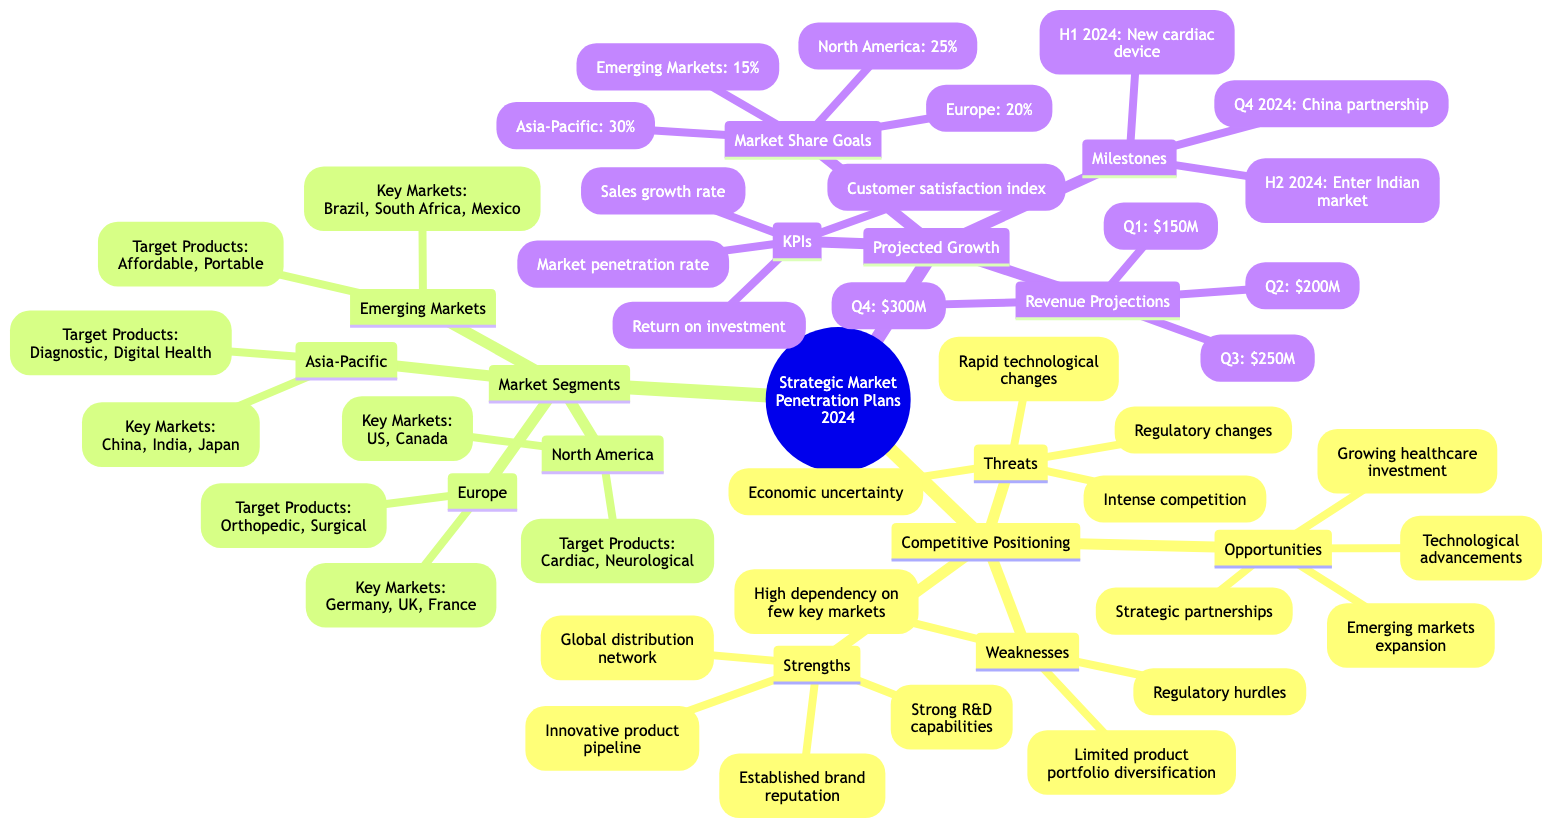What are the strengths listed under competitive positioning? The strengths are explicitly stated in the Competitive Positioning section of the mind map. They include "Innovative product pipeline," "Strong R&D capabilities," "Established brand reputation," and "Global distribution network."
Answer: Innovative product pipeline, Strong R&D capabilities, Established brand reputation, Global distribution network How many key markets are listed for the Asia-Pacific segment? In the Asia-Pacific market segment, there are three key markets mentioned: "China," "India," and "Japan." Therefore, counting these gives us a total of three markets.
Answer: 3 What is the market share goal for North America? The Market Share Goals section specifies the goal for North America. It directly indicates that the target market share is 25%, which is clearly stated in the diagram.
Answer: 25% Which market segment targets affordable healthcare solutions? The Emerging Markets segment mentions "Affordable healthcare solutions" as one of the target products. This clearly indicates which market segment focuses on this aspect.
Answer: Emerging Markets What is the projected revenue for Q3? The Revenue Projections section outlines the projected revenues for each quarter. For Q3, the stated projection is $250 million.
Answer: $250M How many product categories are targeted in the Europe market segment? The Europe market segment lists two target product categories: "Orthopedic devices" and "Surgical instruments." Therefore, the count of product categories is two.
Answer: 2 What is the first milestone for 2024? The Milestones section for Projected Growth indicates that the first milestone in the first half of 2024 is to "Launch new cardiac device." This is a clear statement in the diagram.
Answer: H1 2024: Launch new cardiac device Which factor is listed as a threat in the competitive positioning? In the Competitive Positioning section, several threats are identified. One of them is "Intense competition," which directly highlights the competitive threat facing the company.
Answer: Intense competition What indicates the technological advancements as an opportunity? In the Opportunities section, "Technological advancements" are listed, indicating that the company sees this as a potential area for growth or strategy. This is simply noted within that section of the mind map.
Answer: Technological advancements 